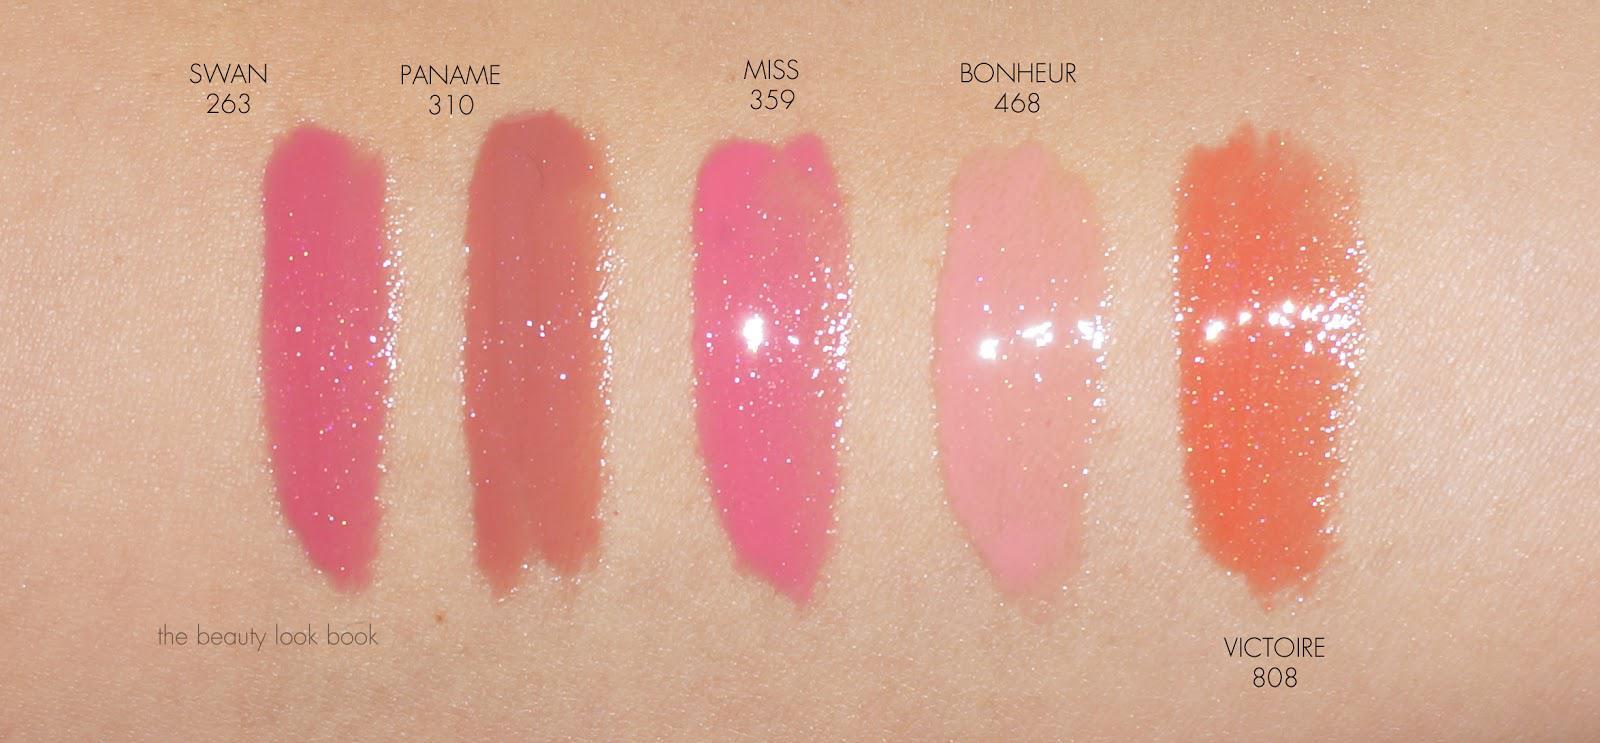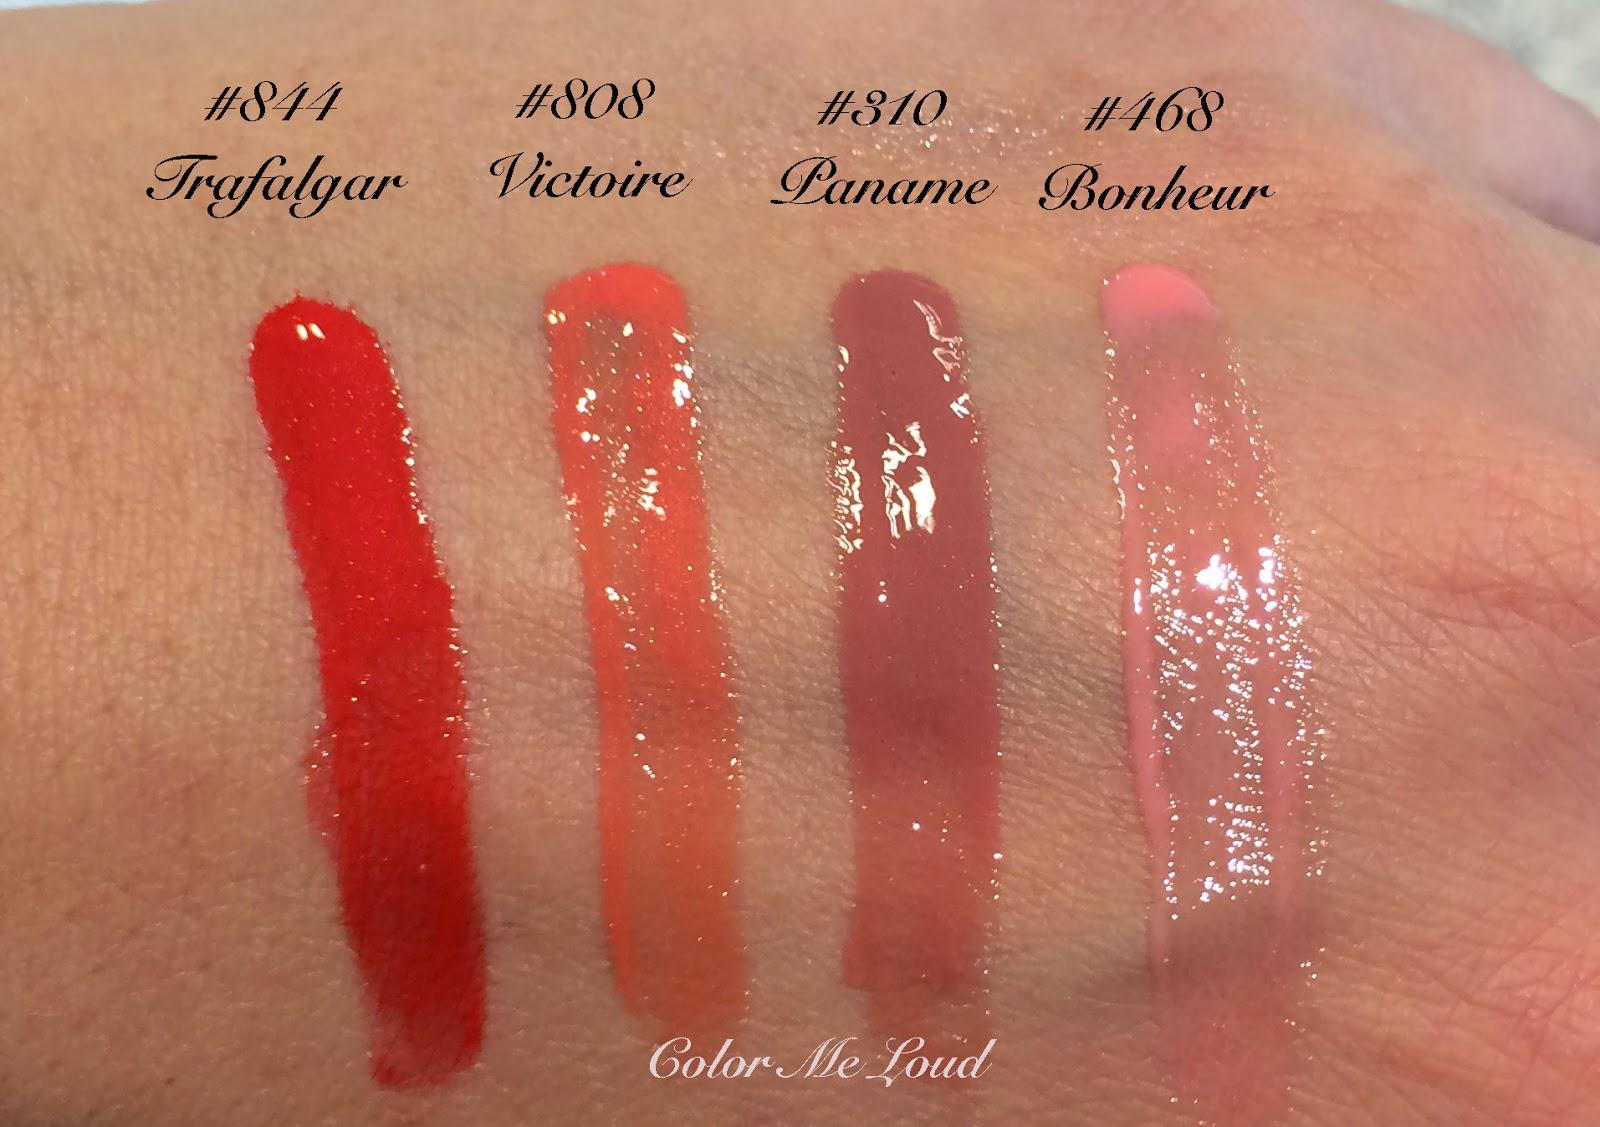The first image is the image on the left, the second image is the image on the right. Assess this claim about the two images: "Color swatches of lip products are on a person's skin.". Correct or not? Answer yes or no. Yes. The first image is the image on the left, the second image is the image on the right. Given the left and right images, does the statement "At least one of the images includes streaks of lip gloss on someone's skin." hold true? Answer yes or no. Yes. 